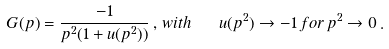Convert formula to latex. <formula><loc_0><loc_0><loc_500><loc_500>G ( p ) = \frac { - 1 } { p ^ { 2 } ( 1 + u ( p ^ { 2 } ) ) } \, , \, w i t h \quad u ( p ^ { 2 } ) \to - 1 \, f o r \, p ^ { 2 } \to 0 \, .</formula> 